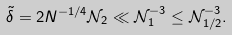<formula> <loc_0><loc_0><loc_500><loc_500>\tilde { \delta } = 2 N ^ { - 1 / 4 } \mathcal { N } _ { 2 } \ll \mathcal { N } _ { 1 } ^ { - 3 } \leq \mathcal { N } _ { 1 / 2 } ^ { - 3 } .</formula> 